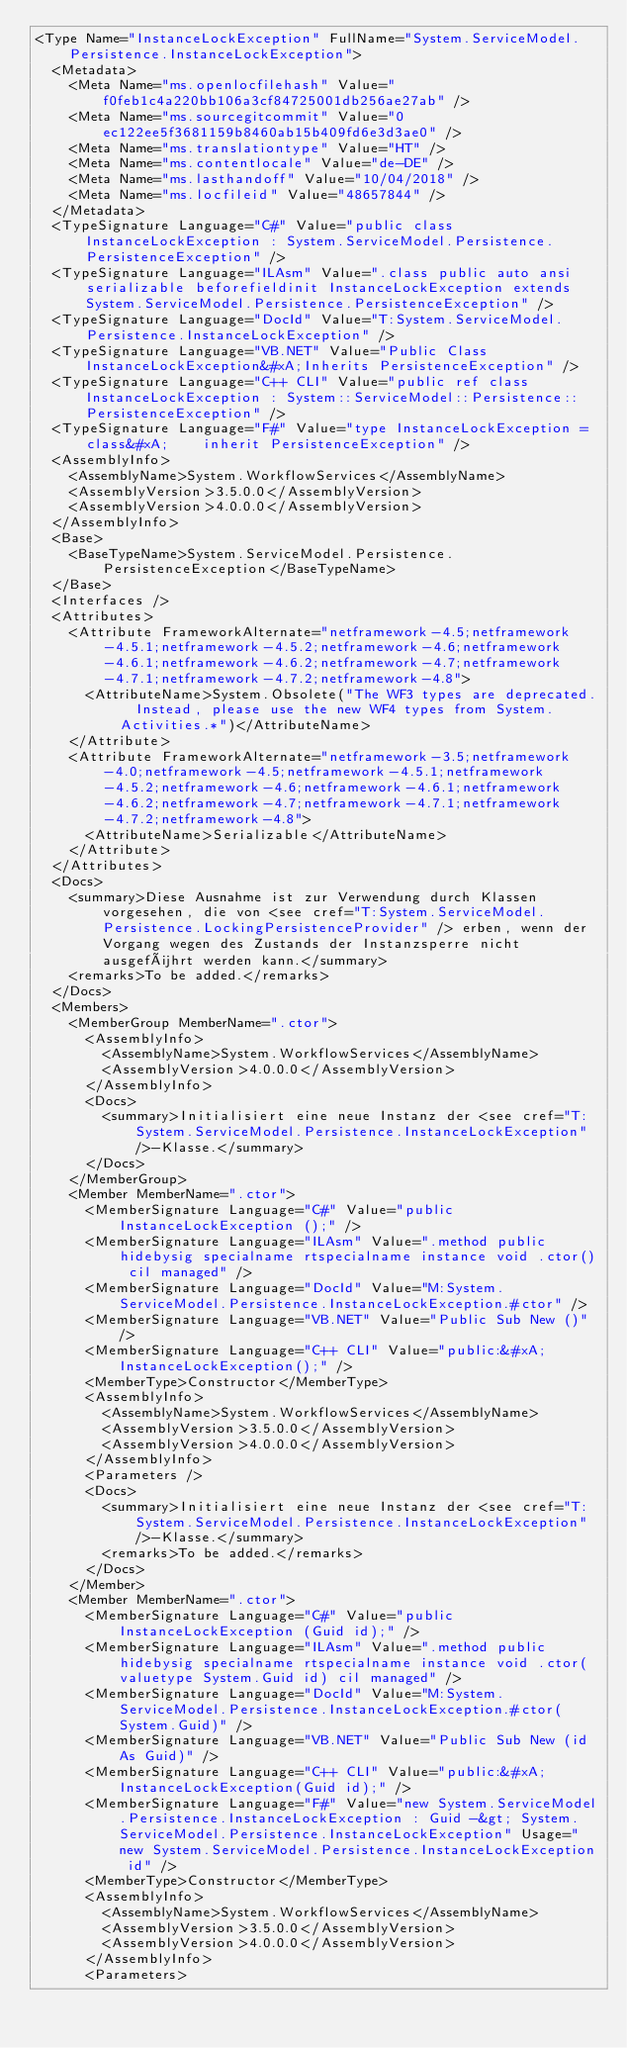<code> <loc_0><loc_0><loc_500><loc_500><_XML_><Type Name="InstanceLockException" FullName="System.ServiceModel.Persistence.InstanceLockException">
  <Metadata>
    <Meta Name="ms.openlocfilehash" Value="f0feb1c4a220bb106a3cf84725001db256ae27ab" />
    <Meta Name="ms.sourcegitcommit" Value="0ec122ee5f3681159b8460ab15b409fd6e3d3ae0" />
    <Meta Name="ms.translationtype" Value="HT" />
    <Meta Name="ms.contentlocale" Value="de-DE" />
    <Meta Name="ms.lasthandoff" Value="10/04/2018" />
    <Meta Name="ms.locfileid" Value="48657844" />
  </Metadata>
  <TypeSignature Language="C#" Value="public class InstanceLockException : System.ServiceModel.Persistence.PersistenceException" />
  <TypeSignature Language="ILAsm" Value=".class public auto ansi serializable beforefieldinit InstanceLockException extends System.ServiceModel.Persistence.PersistenceException" />
  <TypeSignature Language="DocId" Value="T:System.ServiceModel.Persistence.InstanceLockException" />
  <TypeSignature Language="VB.NET" Value="Public Class InstanceLockException&#xA;Inherits PersistenceException" />
  <TypeSignature Language="C++ CLI" Value="public ref class InstanceLockException : System::ServiceModel::Persistence::PersistenceException" />
  <TypeSignature Language="F#" Value="type InstanceLockException = class&#xA;    inherit PersistenceException" />
  <AssemblyInfo>
    <AssemblyName>System.WorkflowServices</AssemblyName>
    <AssemblyVersion>3.5.0.0</AssemblyVersion>
    <AssemblyVersion>4.0.0.0</AssemblyVersion>
  </AssemblyInfo>
  <Base>
    <BaseTypeName>System.ServiceModel.Persistence.PersistenceException</BaseTypeName>
  </Base>
  <Interfaces />
  <Attributes>
    <Attribute FrameworkAlternate="netframework-4.5;netframework-4.5.1;netframework-4.5.2;netframework-4.6;netframework-4.6.1;netframework-4.6.2;netframework-4.7;netframework-4.7.1;netframework-4.7.2;netframework-4.8">
      <AttributeName>System.Obsolete("The WF3 types are deprecated.  Instead, please use the new WF4 types from System.Activities.*")</AttributeName>
    </Attribute>
    <Attribute FrameworkAlternate="netframework-3.5;netframework-4.0;netframework-4.5;netframework-4.5.1;netframework-4.5.2;netframework-4.6;netframework-4.6.1;netframework-4.6.2;netframework-4.7;netframework-4.7.1;netframework-4.7.2;netframework-4.8">
      <AttributeName>Serializable</AttributeName>
    </Attribute>
  </Attributes>
  <Docs>
    <summary>Diese Ausnahme ist zur Verwendung durch Klassen vorgesehen, die von <see cref="T:System.ServiceModel.Persistence.LockingPersistenceProvider" /> erben, wenn der Vorgang wegen des Zustands der Instanzsperre nicht ausgeführt werden kann.</summary>
    <remarks>To be added.</remarks>
  </Docs>
  <Members>
    <MemberGroup MemberName=".ctor">
      <AssemblyInfo>
        <AssemblyName>System.WorkflowServices</AssemblyName>
        <AssemblyVersion>4.0.0.0</AssemblyVersion>
      </AssemblyInfo>
      <Docs>
        <summary>Initialisiert eine neue Instanz der <see cref="T:System.ServiceModel.Persistence.InstanceLockException" />-Klasse.</summary>
      </Docs>
    </MemberGroup>
    <Member MemberName=".ctor">
      <MemberSignature Language="C#" Value="public InstanceLockException ();" />
      <MemberSignature Language="ILAsm" Value=".method public hidebysig specialname rtspecialname instance void .ctor() cil managed" />
      <MemberSignature Language="DocId" Value="M:System.ServiceModel.Persistence.InstanceLockException.#ctor" />
      <MemberSignature Language="VB.NET" Value="Public Sub New ()" />
      <MemberSignature Language="C++ CLI" Value="public:&#xA; InstanceLockException();" />
      <MemberType>Constructor</MemberType>
      <AssemblyInfo>
        <AssemblyName>System.WorkflowServices</AssemblyName>
        <AssemblyVersion>3.5.0.0</AssemblyVersion>
        <AssemblyVersion>4.0.0.0</AssemblyVersion>
      </AssemblyInfo>
      <Parameters />
      <Docs>
        <summary>Initialisiert eine neue Instanz der <see cref="T:System.ServiceModel.Persistence.InstanceLockException" />-Klasse.</summary>
        <remarks>To be added.</remarks>
      </Docs>
    </Member>
    <Member MemberName=".ctor">
      <MemberSignature Language="C#" Value="public InstanceLockException (Guid id);" />
      <MemberSignature Language="ILAsm" Value=".method public hidebysig specialname rtspecialname instance void .ctor(valuetype System.Guid id) cil managed" />
      <MemberSignature Language="DocId" Value="M:System.ServiceModel.Persistence.InstanceLockException.#ctor(System.Guid)" />
      <MemberSignature Language="VB.NET" Value="Public Sub New (id As Guid)" />
      <MemberSignature Language="C++ CLI" Value="public:&#xA; InstanceLockException(Guid id);" />
      <MemberSignature Language="F#" Value="new System.ServiceModel.Persistence.InstanceLockException : Guid -&gt; System.ServiceModel.Persistence.InstanceLockException" Usage="new System.ServiceModel.Persistence.InstanceLockException id" />
      <MemberType>Constructor</MemberType>
      <AssemblyInfo>
        <AssemblyName>System.WorkflowServices</AssemblyName>
        <AssemblyVersion>3.5.0.0</AssemblyVersion>
        <AssemblyVersion>4.0.0.0</AssemblyVersion>
      </AssemblyInfo>
      <Parameters></code> 